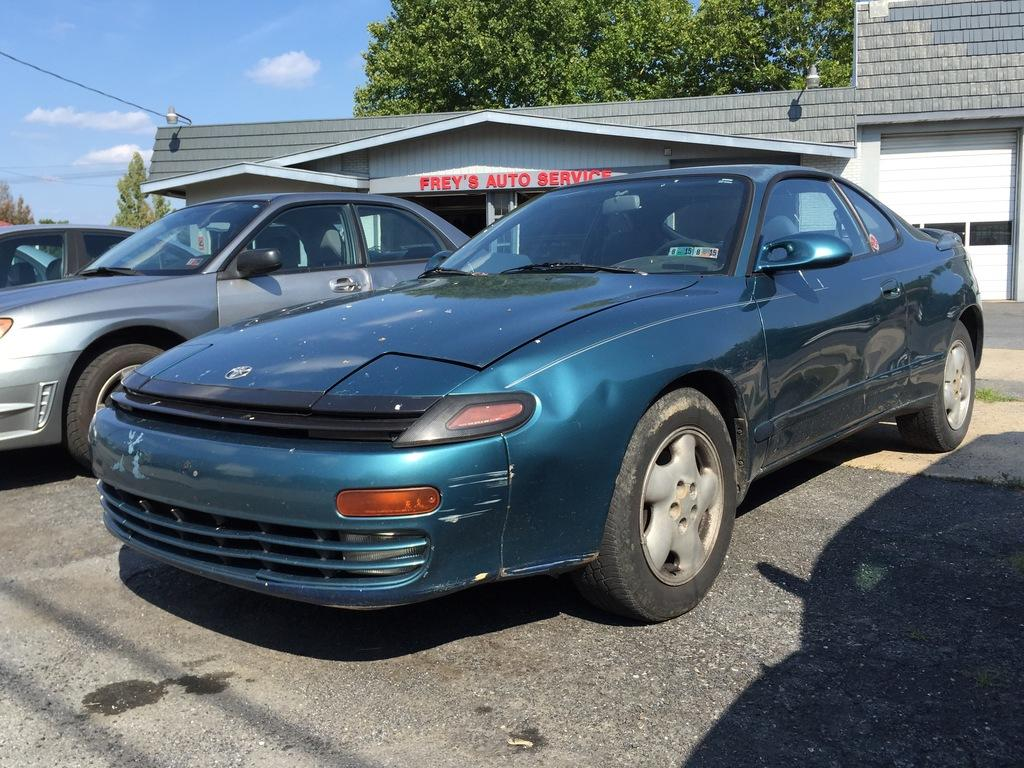What type of vehicles can be seen on the road in the image? There are cars on the road in the image. What is located in the background of the image? There is a building and trees in the background of the image. What is visible at the top of the image? The sky is visible at the top of the image. What else can be seen in the image? There is a wire visible in the image. What type of jewel can be seen on the wire in the image? There is no jewel present on the wire in the image. How many frogs are sitting on the cars in the image? There are no frogs present in the image; it only features cars on the road. 